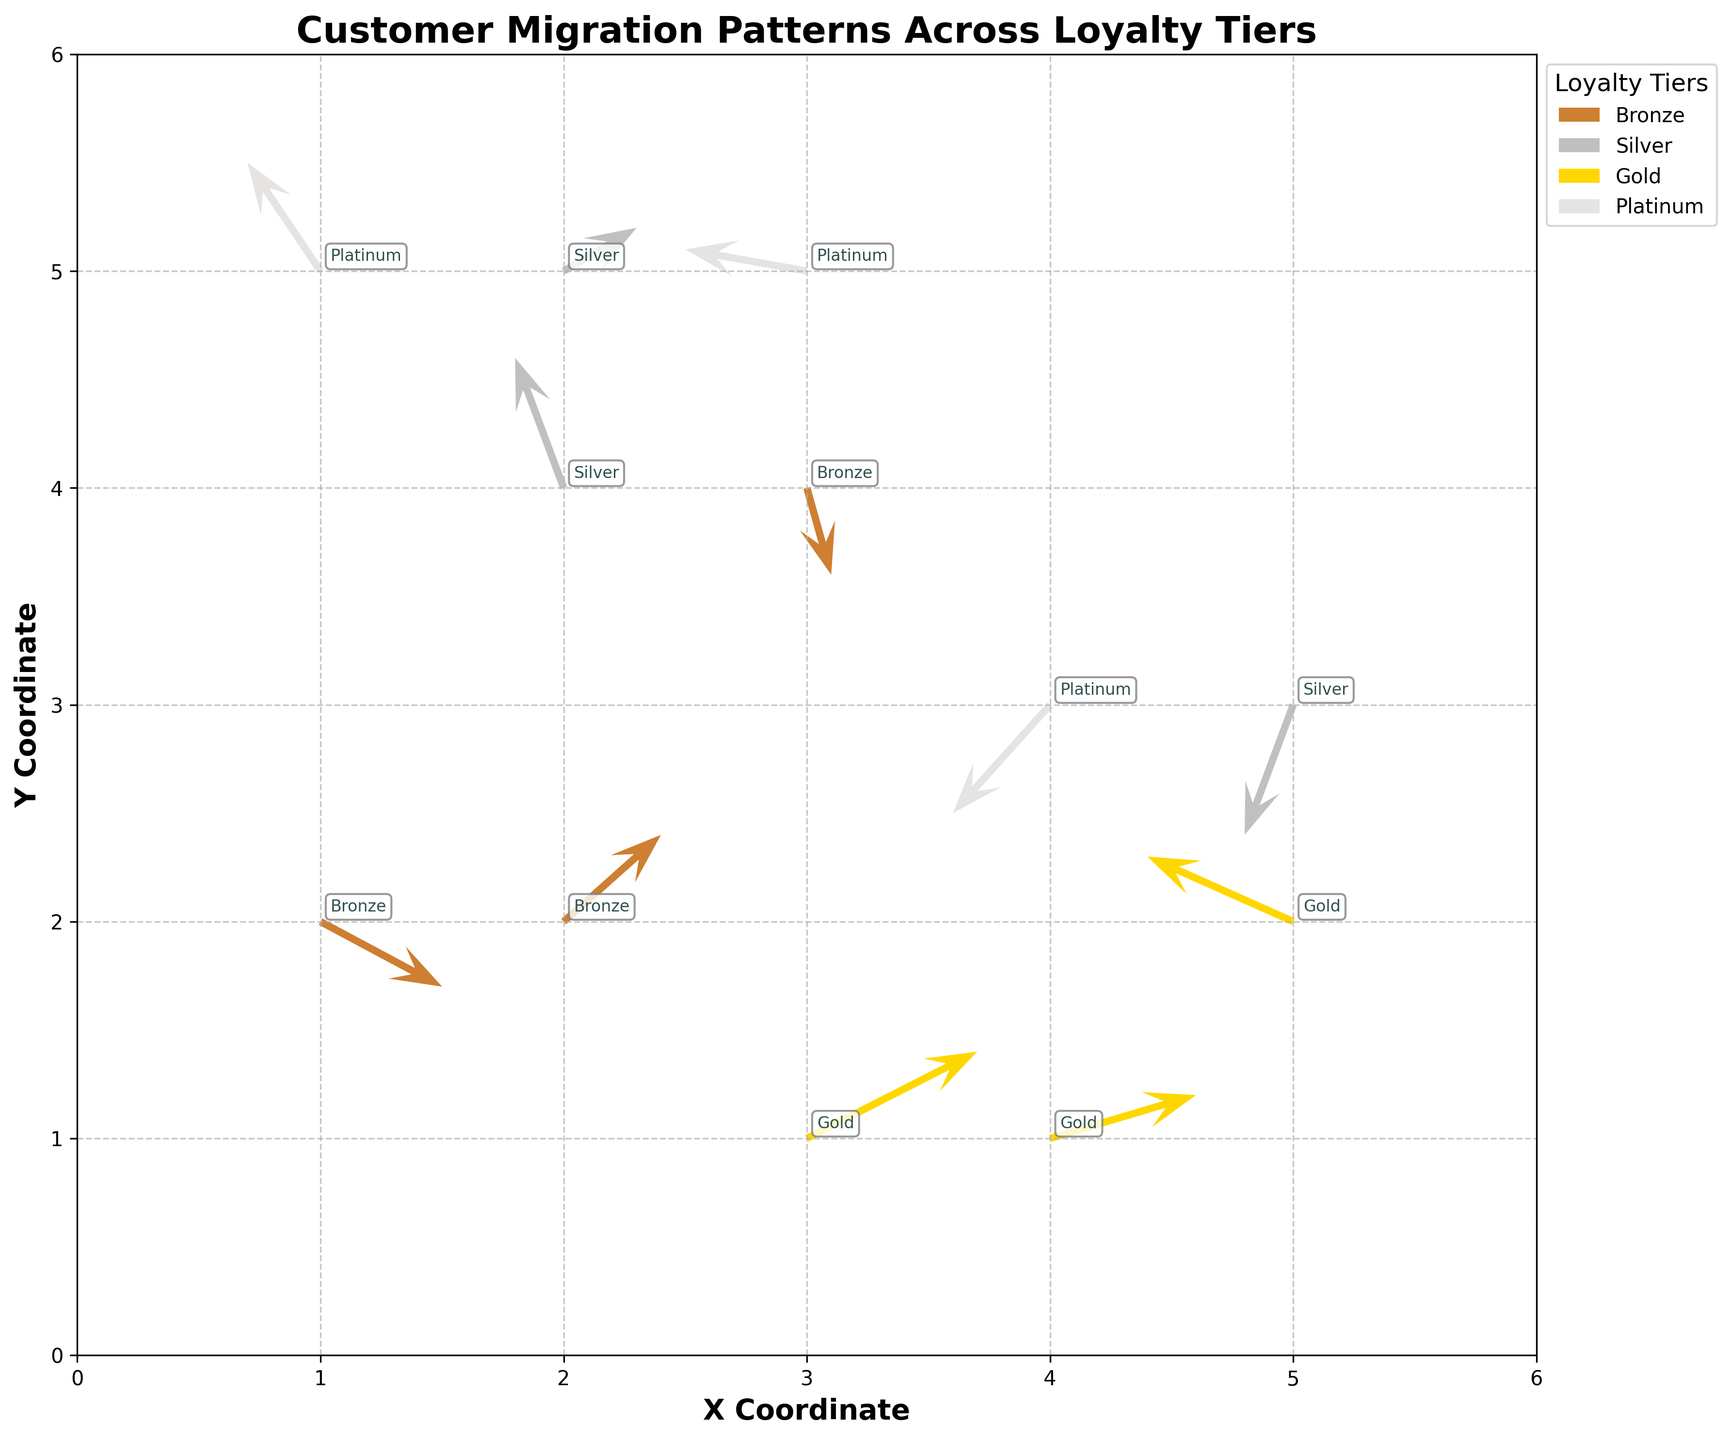what is the title of the figure? The title is located at the top center of the plot, usually in a larger and bolder font to indicate the main topic of the visualization.
Answer: "Customer Migration Patterns Across Loyalty Tiers" How many loyalty tiers are represented in the plot? The plot uses a legend to identify the different colors corresponding to the loyalty tiers. Each unique color in the legend represents a distinct tier.
Answer: 4 Which loyalty tier has the quiver originating from the highest X coordinate? By observing the quivers, the one that starts from the highest X coordinate (5) can be identified. The annotation at this origin indicates the tier.
Answer: Gold What is the primary direction of movement for Bronze tier customers? The main direction of movement can be determined by looking at the arrows (u, v values) starting from points annotated as Bronze. Most of these arrows generally point in a consistent direction.
Answer: Positive X and Positive Y How many quivers have their direction close to vertical (primary movement in Y direction)? Quivers where u (X component) is significantly smaller than v (Y component) indicate a primary vertical direction. Counting these arrows gives us the answer.
Answer: 3 Which tier shows the most significant downward movement? Determine the most significant negative v (Y component) value and identify the tier from the figure.
Answer: Platinum Compare the movement of customers in the Silver tier starting from (2,4) and (5,3). Which direction shows a greater displacement in X direction? To compare the displacements, check the 'u' values for the Silver tier starting from (2,4) and (5,3). The greater absolute value of 'u' will reveal the bigger displacement.
Answer: (2,4) Do customers in the Gold tier show a tendency to move leftwards, rightwards, upwards, or downwards? Analyze the 'u' and 'v' components of the quivers starting from points annotated as Gold. Majority direction between leftwards or rightwards (X-axis) and upwards or downwards (Y-axis).
Answer: Rightwards and Upwards Which point has the quiver with the longest magnitude? Calculate the magnitude of each quiver using the formula sqrt(u^2 + v^2), and find the point with the highest value.
Answer: (3,1) What is the predominant migration pattern for customers originating from the lower left region of the plot (X ≤ 3, Y ≤ 3)? Examine the direction and length of the quivers starting from points within the specified region to determine the predominant migration pattern.
Answer: Positive X direction and Positive Y direction 